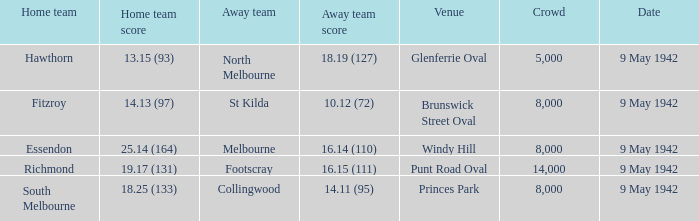25 (133)? 8000.0. 